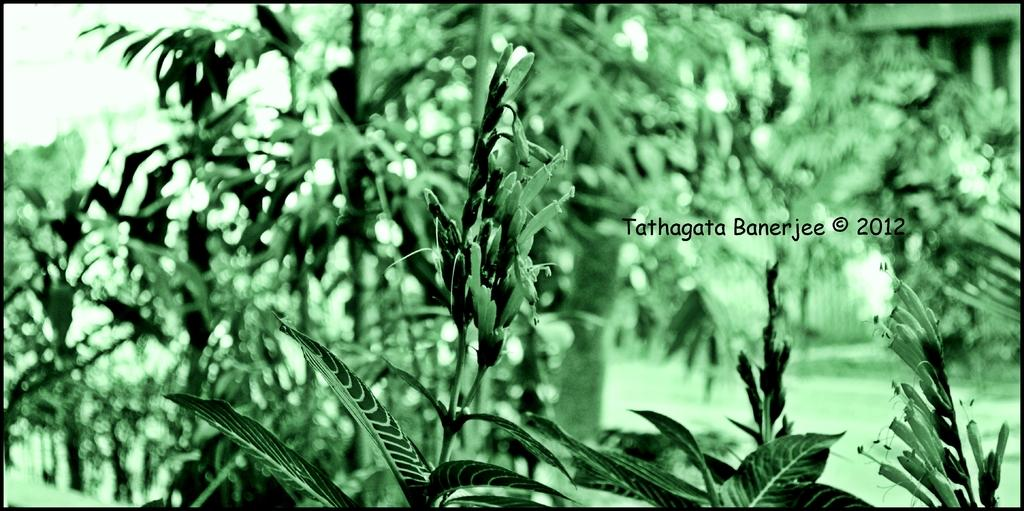What can be observed about the image's appearance? The image is edited. What types of vegetation can be seen in the image? There are different types of plants and trees in the image. What type of muscle is visible in the image? There is no muscle visible in the image; it primarily features plants and trees. 